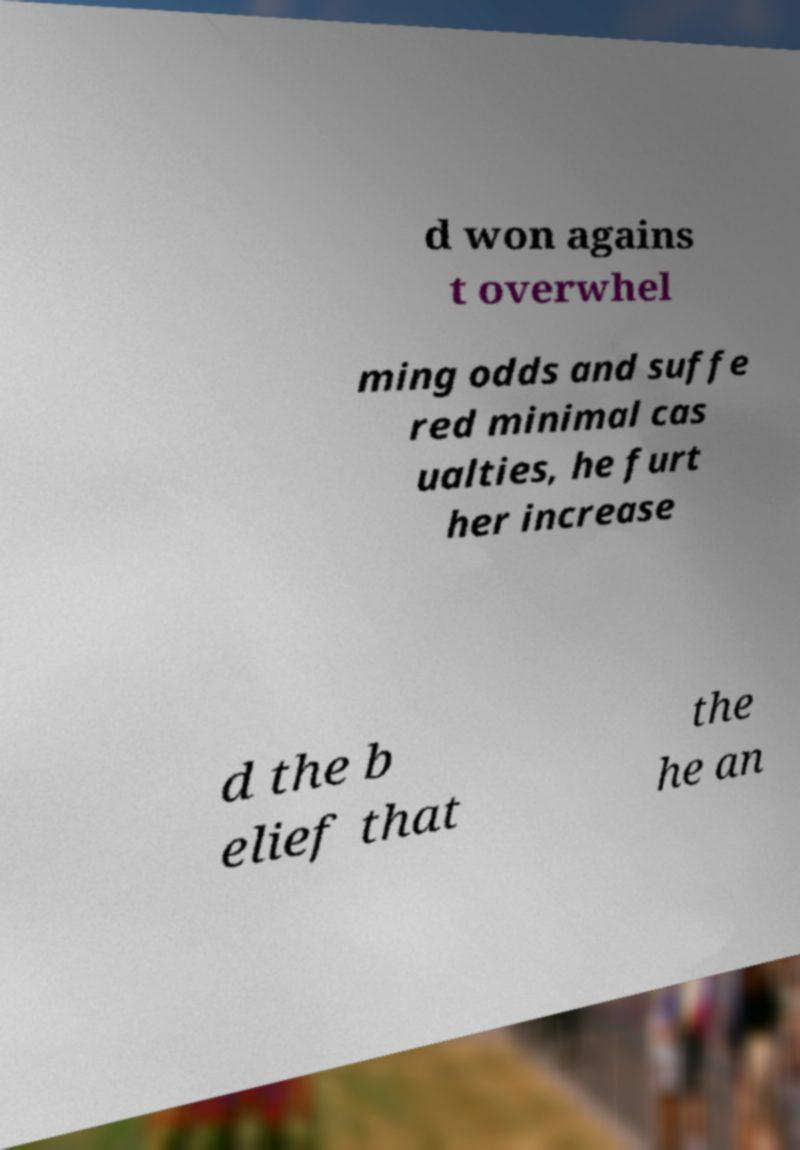For documentation purposes, I need the text within this image transcribed. Could you provide that? d won agains t overwhel ming odds and suffe red minimal cas ualties, he furt her increase d the b elief that the he an 